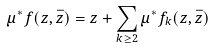<formula> <loc_0><loc_0><loc_500><loc_500>\mu ^ { * } f ( z , \bar { z } ) = z + \sum _ { k \geq 2 } \mu ^ { * } f _ { k } ( z , \bar { z } )</formula> 